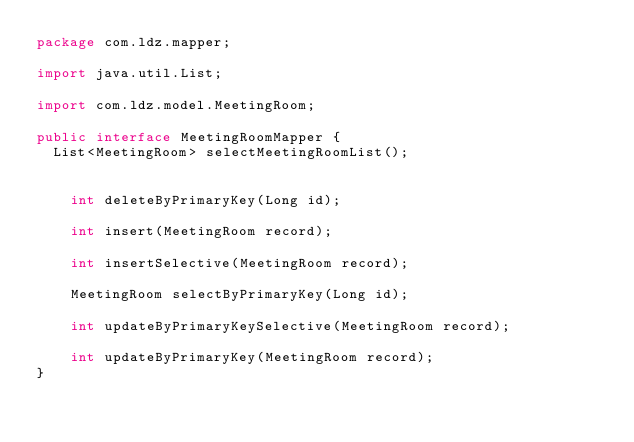Convert code to text. <code><loc_0><loc_0><loc_500><loc_500><_Java_>package com.ldz.mapper;

import java.util.List;

import com.ldz.model.MeetingRoom;

public interface MeetingRoomMapper {
	List<MeetingRoom> selectMeetingRoomList();
	
	
    int deleteByPrimaryKey(Long id);

    int insert(MeetingRoom record);

    int insertSelective(MeetingRoom record);

    MeetingRoom selectByPrimaryKey(Long id);

    int updateByPrimaryKeySelective(MeetingRoom record);

    int updateByPrimaryKey(MeetingRoom record);
}</code> 